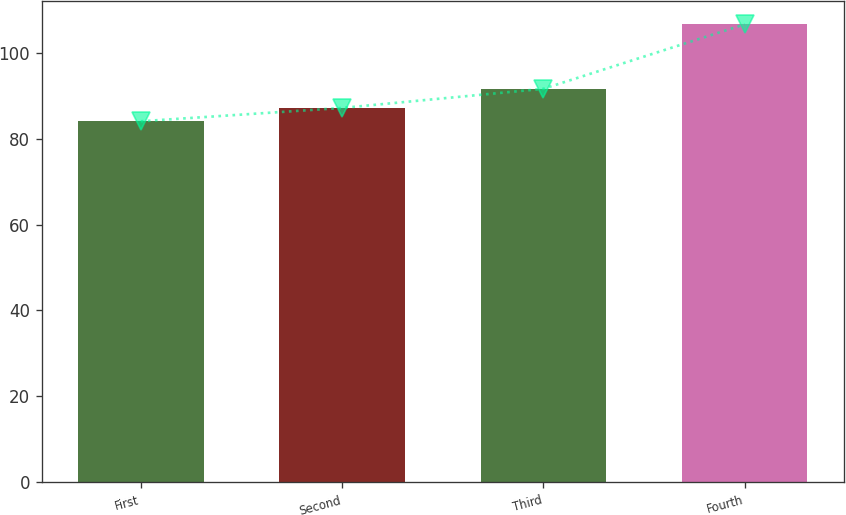<chart> <loc_0><loc_0><loc_500><loc_500><bar_chart><fcel>First<fcel>Second<fcel>Third<fcel>Fourth<nl><fcel>84.02<fcel>87.12<fcel>91.57<fcel>106.57<nl></chart> 